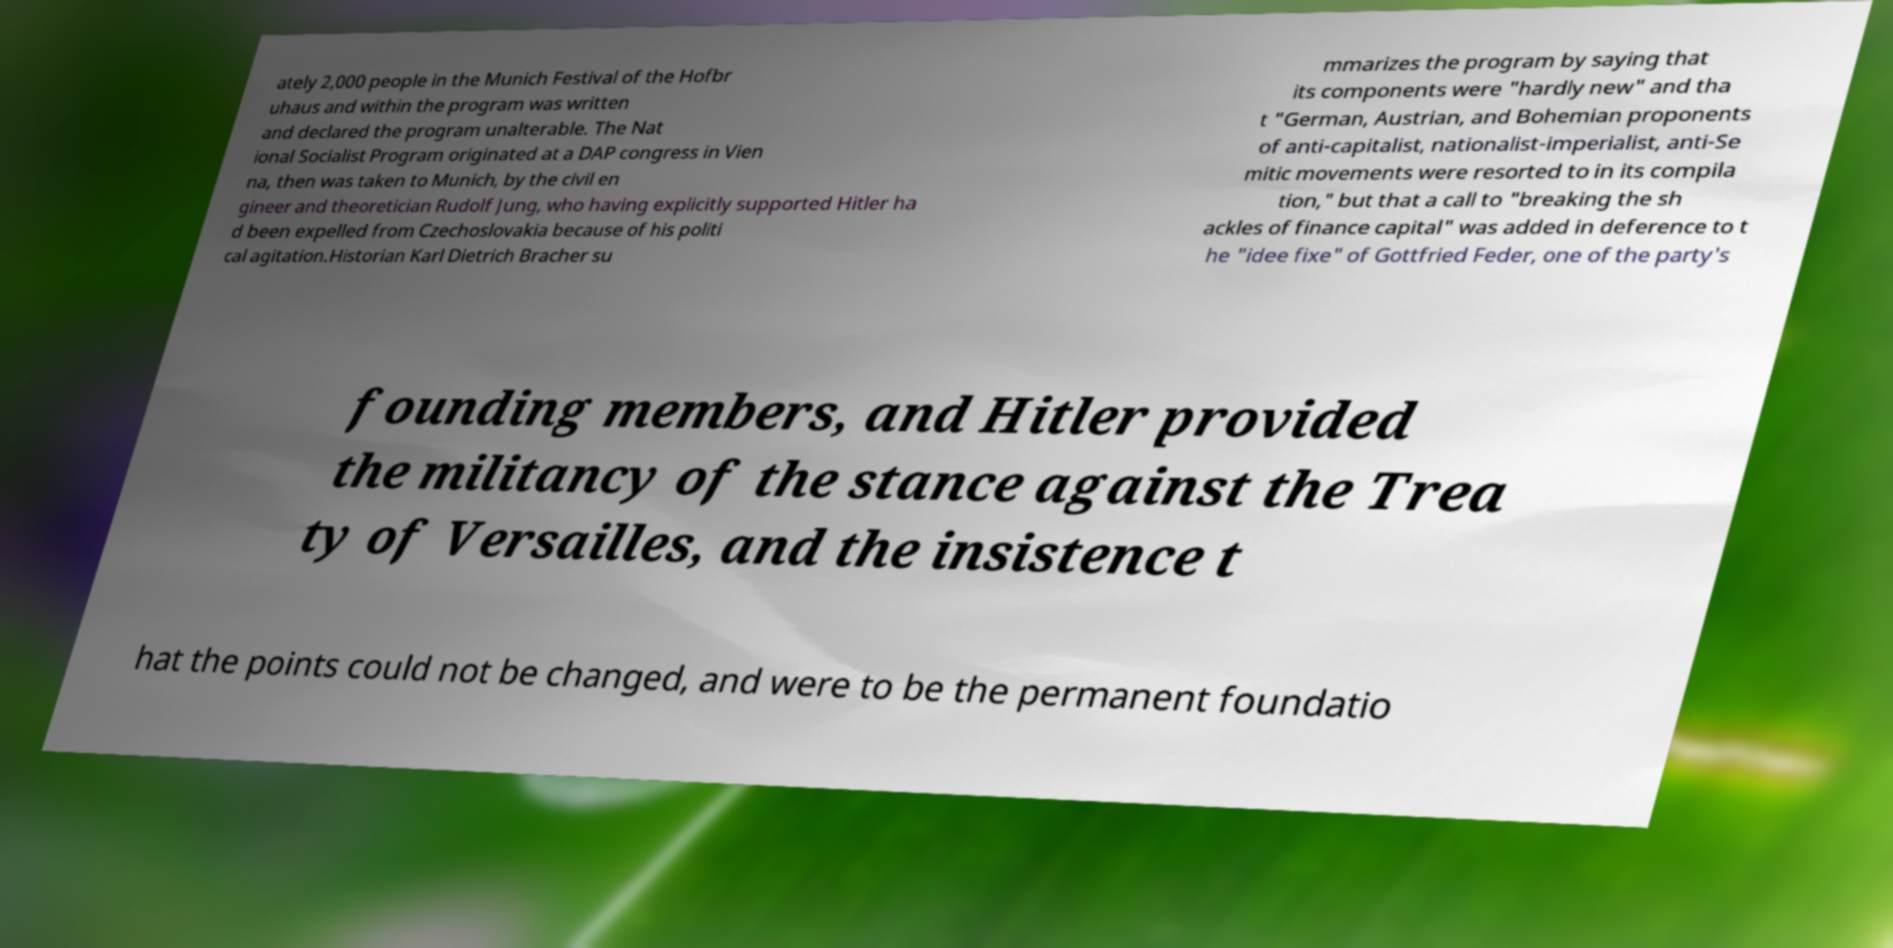There's text embedded in this image that I need extracted. Can you transcribe it verbatim? ately 2,000 people in the Munich Festival of the Hofbr uhaus and within the program was written and declared the program unalterable. The Nat ional Socialist Program originated at a DAP congress in Vien na, then was taken to Munich, by the civil en gineer and theoretician Rudolf Jung, who having explicitly supported Hitler ha d been expelled from Czechoslovakia because of his politi cal agitation.Historian Karl Dietrich Bracher su mmarizes the program by saying that its components were "hardly new" and tha t "German, Austrian, and Bohemian proponents of anti-capitalist, nationalist-imperialist, anti-Se mitic movements were resorted to in its compila tion," but that a call to "breaking the sh ackles of finance capital" was added in deference to t he "idee fixe" of Gottfried Feder, one of the party's founding members, and Hitler provided the militancy of the stance against the Trea ty of Versailles, and the insistence t hat the points could not be changed, and were to be the permanent foundatio 